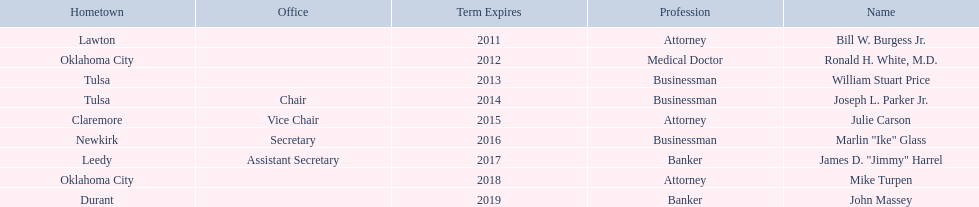From which state's regent does dr. ronald h. white, m.d. have the same hometown as? Mike Turpen. 